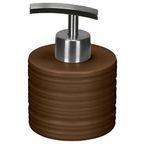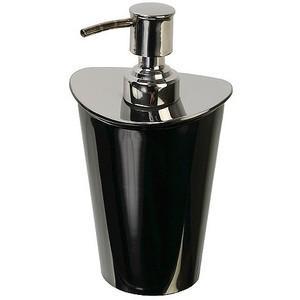The first image is the image on the left, the second image is the image on the right. Assess this claim about the two images: "The right image contains a black dispenser with a chrome top.". Correct or not? Answer yes or no. Yes. 